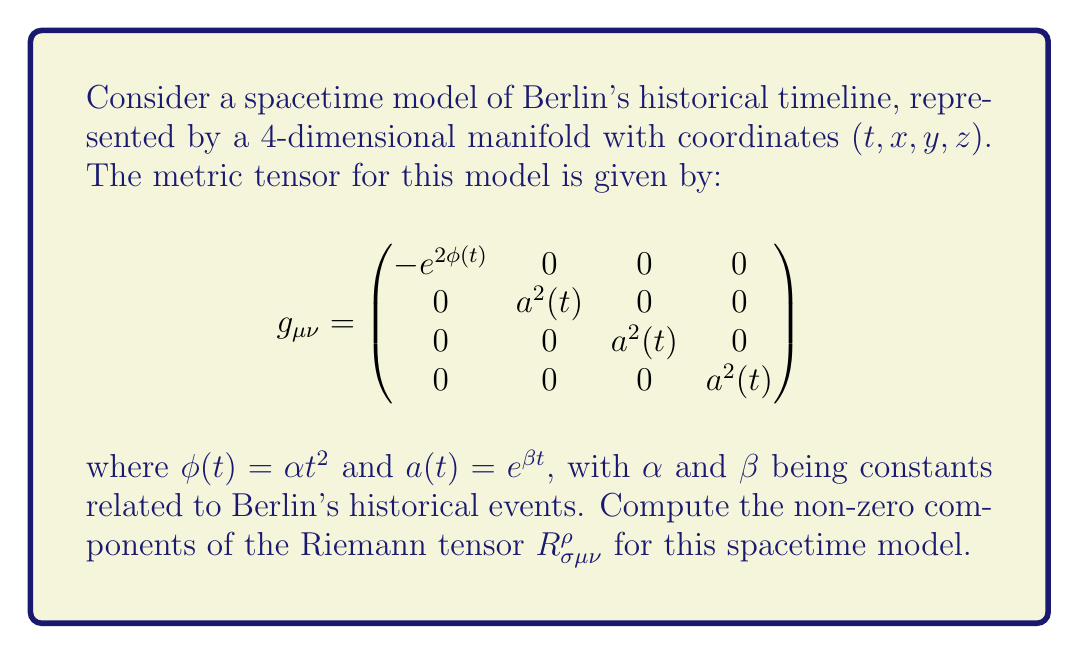Provide a solution to this math problem. To compute the Riemann tensor, we'll follow these steps:

1) First, we need to calculate the Christoffel symbols $\Gamma^\rho_{\mu\nu}$ using the formula:

   $$\Gamma^\rho_{\mu\nu} = \frac{1}{2}g^{\rho\sigma}(\partial_\mu g_{\nu\sigma} + \partial_\nu g_{\mu\sigma} - \partial_\sigma g_{\mu\nu})$$

2) The non-zero Christoffel symbols are:

   $$\Gamma^0_{00} = \phi'(t) = 2\alpha t$$
   $$\Gamma^i_{0i} = \Gamma^i_{i0} = \frac{a'(t)}{a(t)} = \beta \quad (i = 1,2,3)$$
   $$\Gamma^0_{ii} = \beta a^2(t)e^{-2\phi(t)} \quad (i = 1,2,3)$$

3) Now, we can compute the Riemann tensor using the formula:

   $$R^\rho_{\sigma\mu\nu} = \partial_\mu \Gamma^\rho_{\nu\sigma} - \partial_\nu \Gamma^\rho_{\mu\sigma} + \Gamma^\rho_{\mu\lambda}\Gamma^\lambda_{\nu\sigma} - \Gamma^\rho_{\nu\lambda}\Gamma^\lambda_{\mu\sigma}$$

4) The non-zero components are:

   $$R^0_{i0i} = -R^0_{i00} = -(\beta^2 + 2\alpha)e^{2\phi(t)} \quad (i = 1,2,3)$$
   $$R^i_{0j0} = -(\beta^2 + 2\alpha)\delta^i_j \quad (i,j = 1,2,3)$$
   $$R^i_{jkl} = \beta^2(δ^i_k g_{jl} - δ^i_l g_{jk}) \quad (i,j,k,l = 1,2,3)$$

5) Substituting the expressions for $\phi(t)$ and $a(t)$:

   $$R^0_{i0i} = -R^0_{i00} = -(\beta^2 + 2\alpha)e^{2\alpha t^2} \quad (i = 1,2,3)$$
   $$R^i_{0j0} = -(\beta^2 + 2\alpha)\delta^i_j \quad (i,j = 1,2,3)$$
   $$R^i_{jkl} = \beta^2(δ^i_k δ_{jl} - δ^i_l δ_{jk})e^{2\beta t} \quad (i,j,k,l = 1,2,3)$$
Answer: $R^0_{i0i} = -R^0_{i00} = -(\beta^2 + 2\alpha)e^{2\alpha t^2}$, $R^i_{0j0} = -(\beta^2 + 2\alpha)\delta^i_j$, $R^i_{jkl} = \beta^2(δ^i_k δ_{jl} - δ^i_l δ_{jk})e^{2\beta t}$ $(i,j,k,l = 1,2,3)$ 